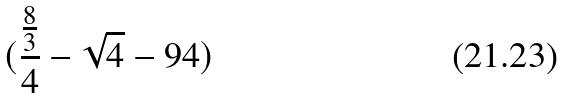Convert formula to latex. <formula><loc_0><loc_0><loc_500><loc_500>( \frac { \frac { 8 } { 3 } } { 4 } - \sqrt { 4 } - 9 4 )</formula> 